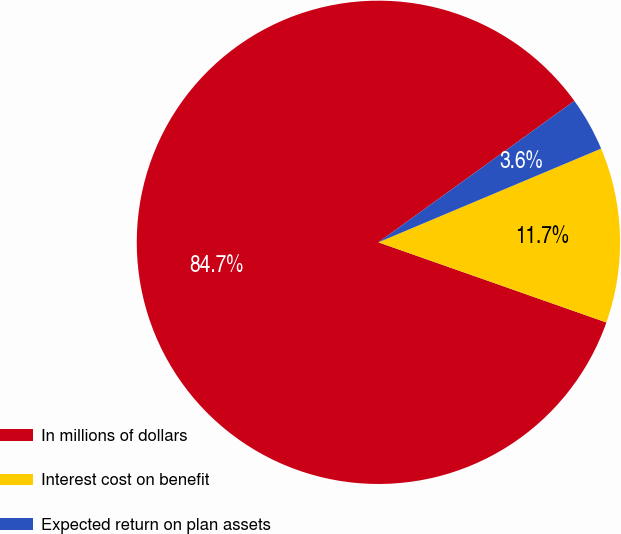Convert chart. <chart><loc_0><loc_0><loc_500><loc_500><pie_chart><fcel>In millions of dollars<fcel>Interest cost on benefit<fcel>Expected return on plan assets<nl><fcel>84.67%<fcel>11.72%<fcel>3.61%<nl></chart> 